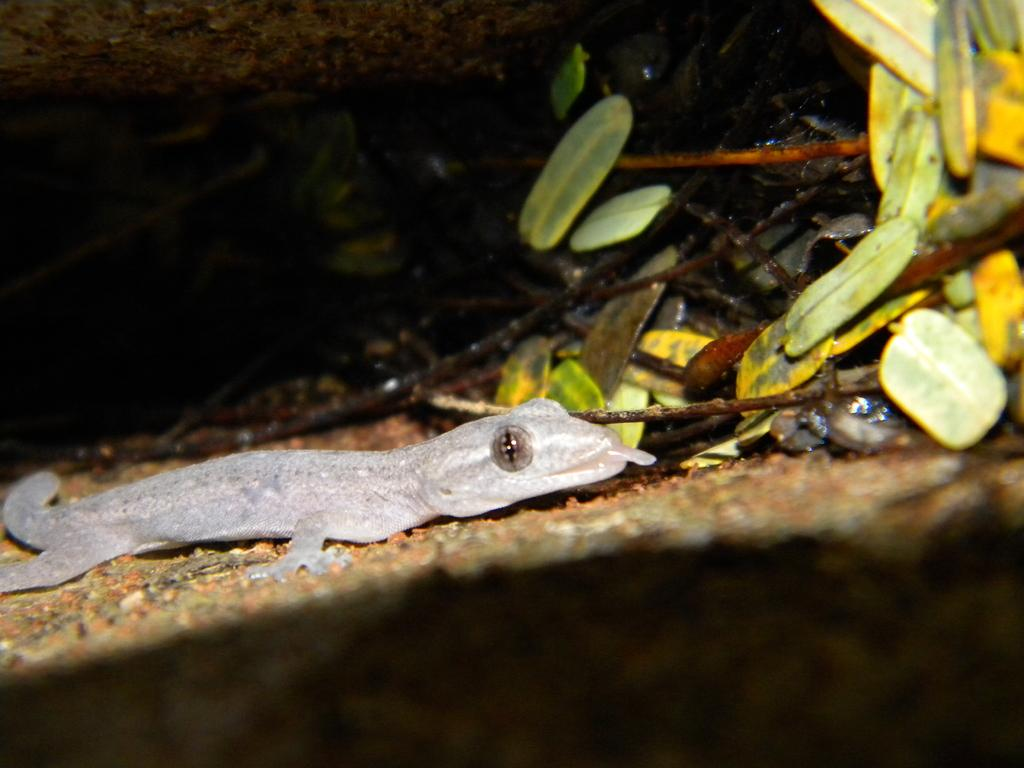What type of animal is in the image? There is a reptile in the image. What can be seen in the background of the image? There are leaves, twigs, and a tree trunk in the background of the image. What type of calculator is being used by the reptile in the image? There is no calculator present in the image; it features a reptile and natural background elements. 